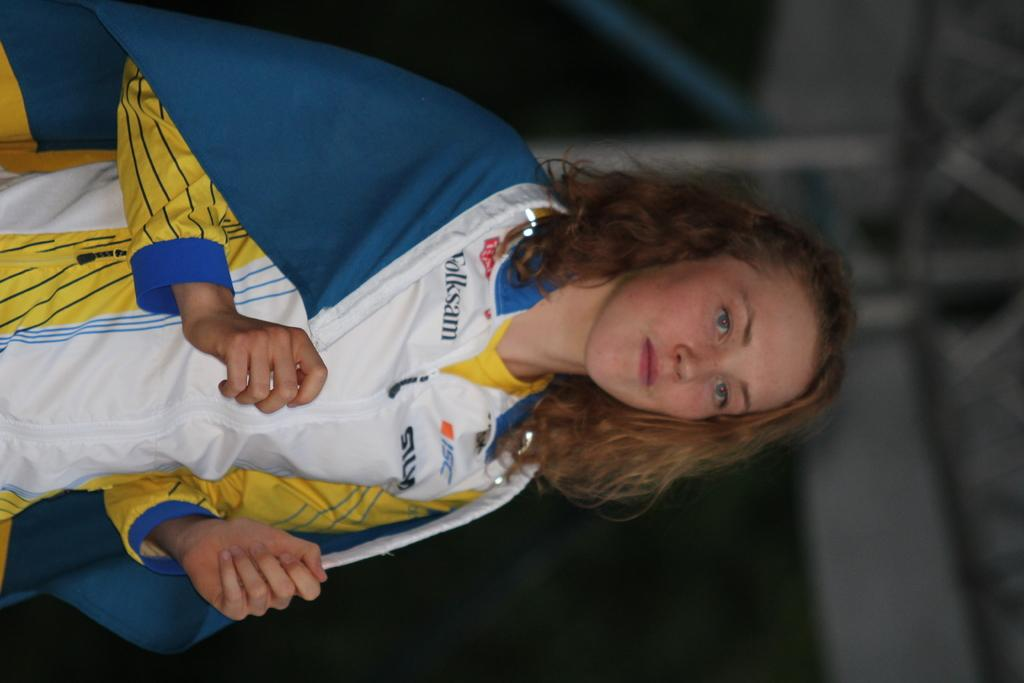<image>
Present a compact description of the photo's key features. A young woman with a sponsored shirt, including the sponsors Folksam and ISC, is standing with a blue flag draped over her shoulders. 